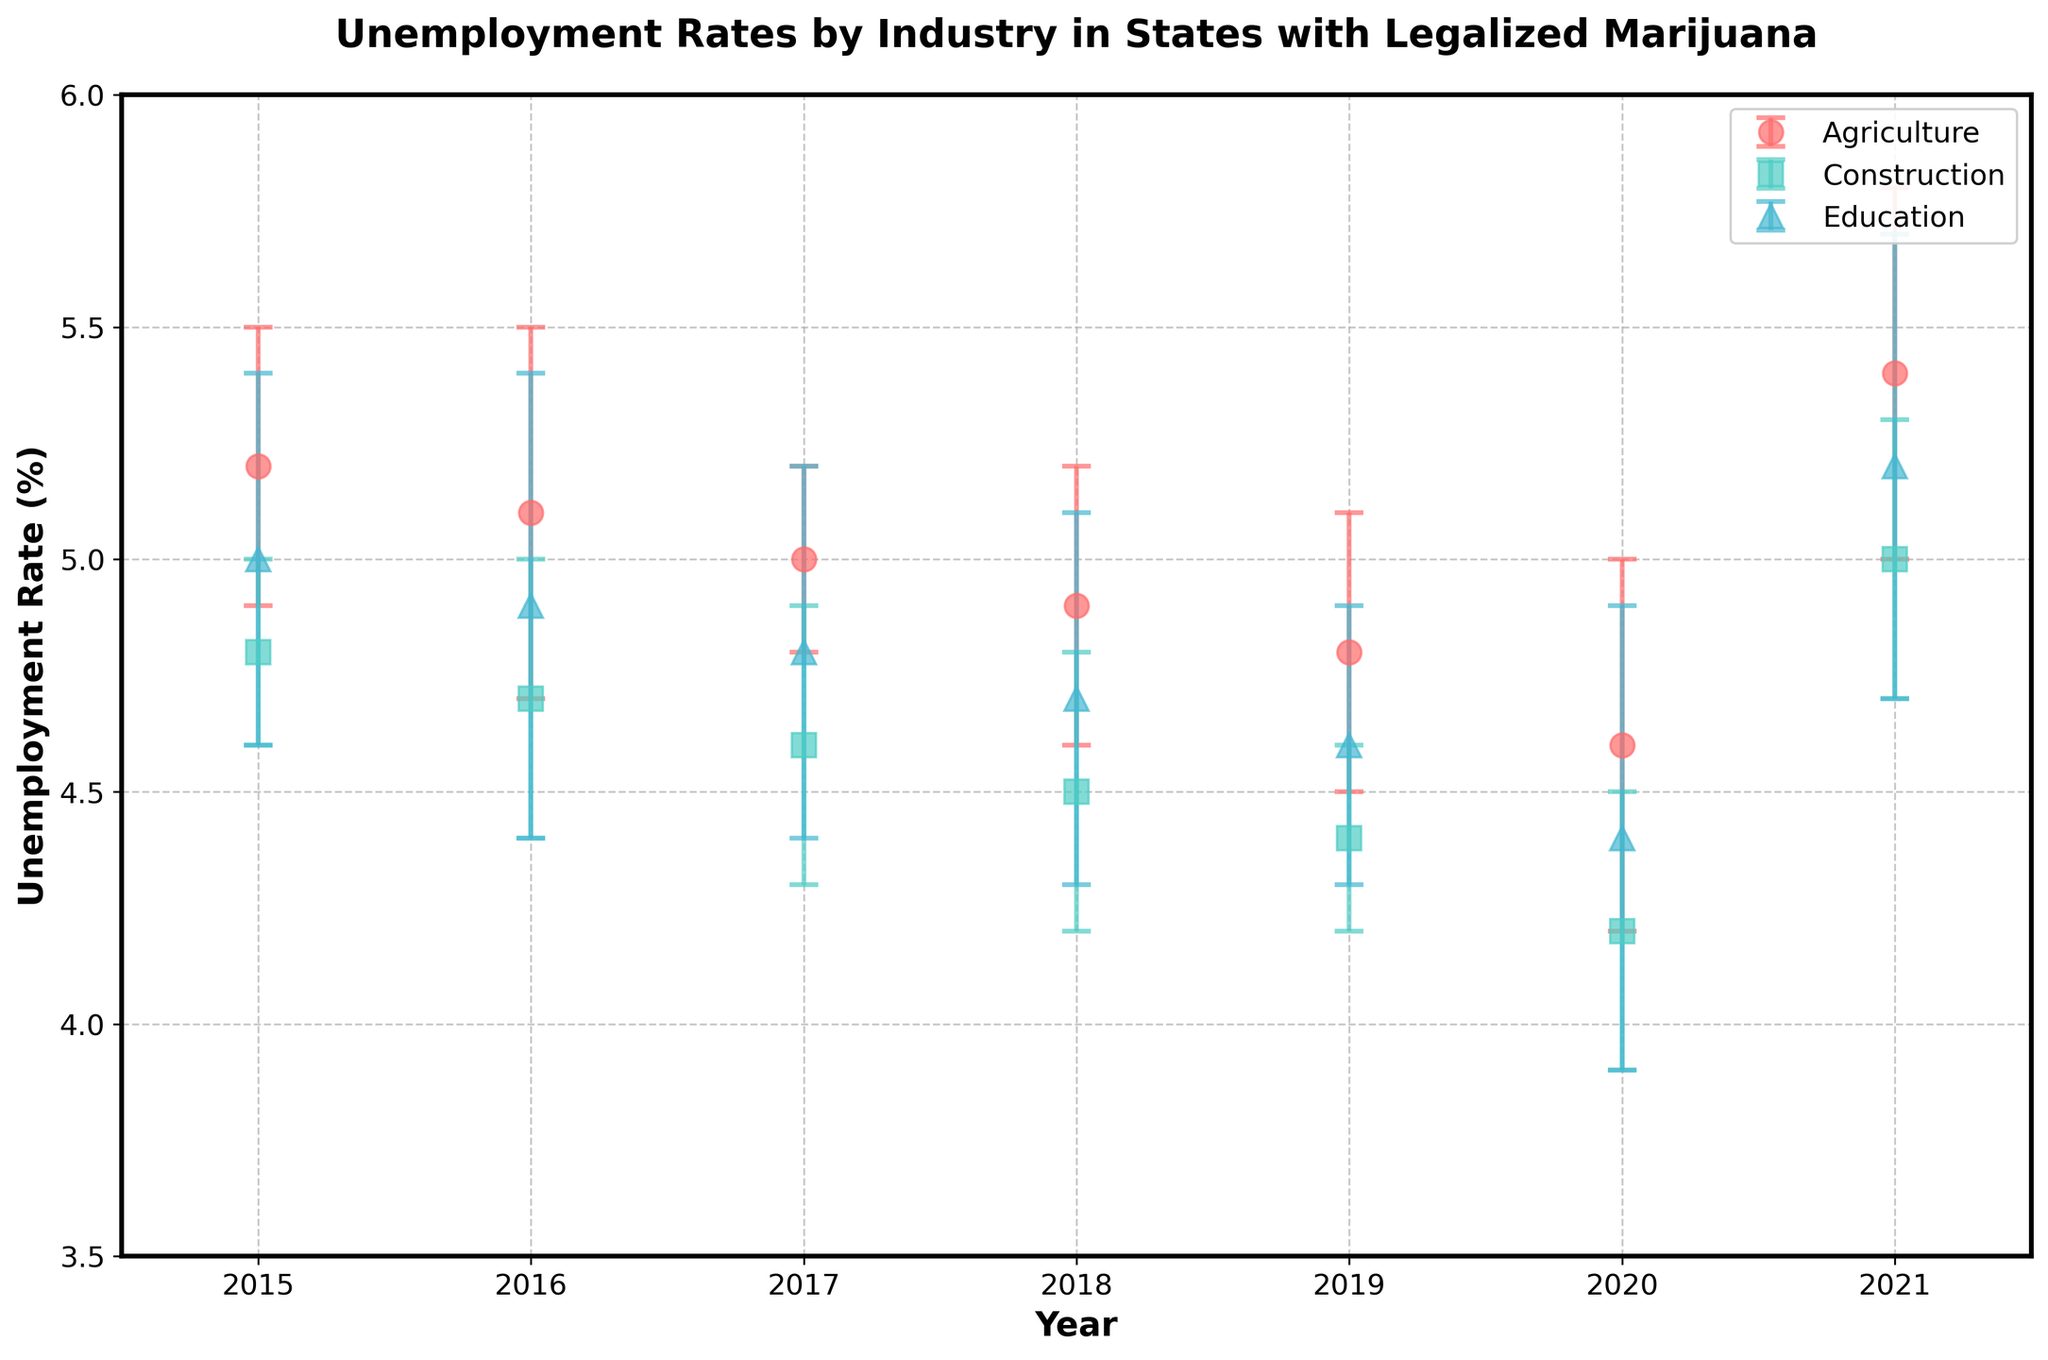What is the title of the plot? The title is displayed at the top of the scatter plot and reads, "Unemployment Rates by Industry in States with Legalized Marijuana."
Answer: Unemployment Rates by Industry in States with Legalized Marijuana Which year shows the lowest unemployment rate for the Education industry? By observing the markers representing the Education industry across the years, the lowest unemployment rate for the Education industry is in 2020.
Answer: 2020 How did the unemployment rate in the Agriculture industry change from 2015 to 2021? Looking at the error bars for the Agriculture industry markers, we see that the unemployment rate decreased from 5.2% in 2015 to 4.6% in 2020 and then increased to 5.4% in 2021.
Answer: Decreased then increased Which two years had both the highest and lowest average unemployment rates across all industries? To determine the highest and lowest averages, we calculate the mean unemployment rate for each year by averaging the rates of all industries. From the plot, 2021 has the highest average (approx. 5.2%) and 2020 the lowest average (approx. 4.43%).
Answer: Highest: 2021, Lowest: 2020 Comparing the Construction industry in 2015 and 2021, which had a lower unemployment rate? Observing the markers for the Construction industry in 2015 and 2021, 2021 has a higher unemployment rate (5.0%) compared to 2015 (4.8%).
Answer: 2015 What is the range of the error bars for the Education industry in 2016? For 2016, the error for the Education industry is ±0.5%, so with a mean of 4.9%, the range is from 4.4% to 5.4%.
Answer: 4.4% to 5.4% In which year did the Agricultural industry have the smallest error margin, and what was it? By observing the length of the error bars for the Agriculture industry for each year, the smallest error margin was in 2017, with an error of 0.2%.
Answer: 2017, 0.2% Which industry in California had the highest unemployment rate in 2017? Referring to the markers representing three industries in California for the year 2017, Agriculture and Education both show higher unemployment rates (5% and 4.8%, respectively) compared to Construction.
Answer: Agriculture 